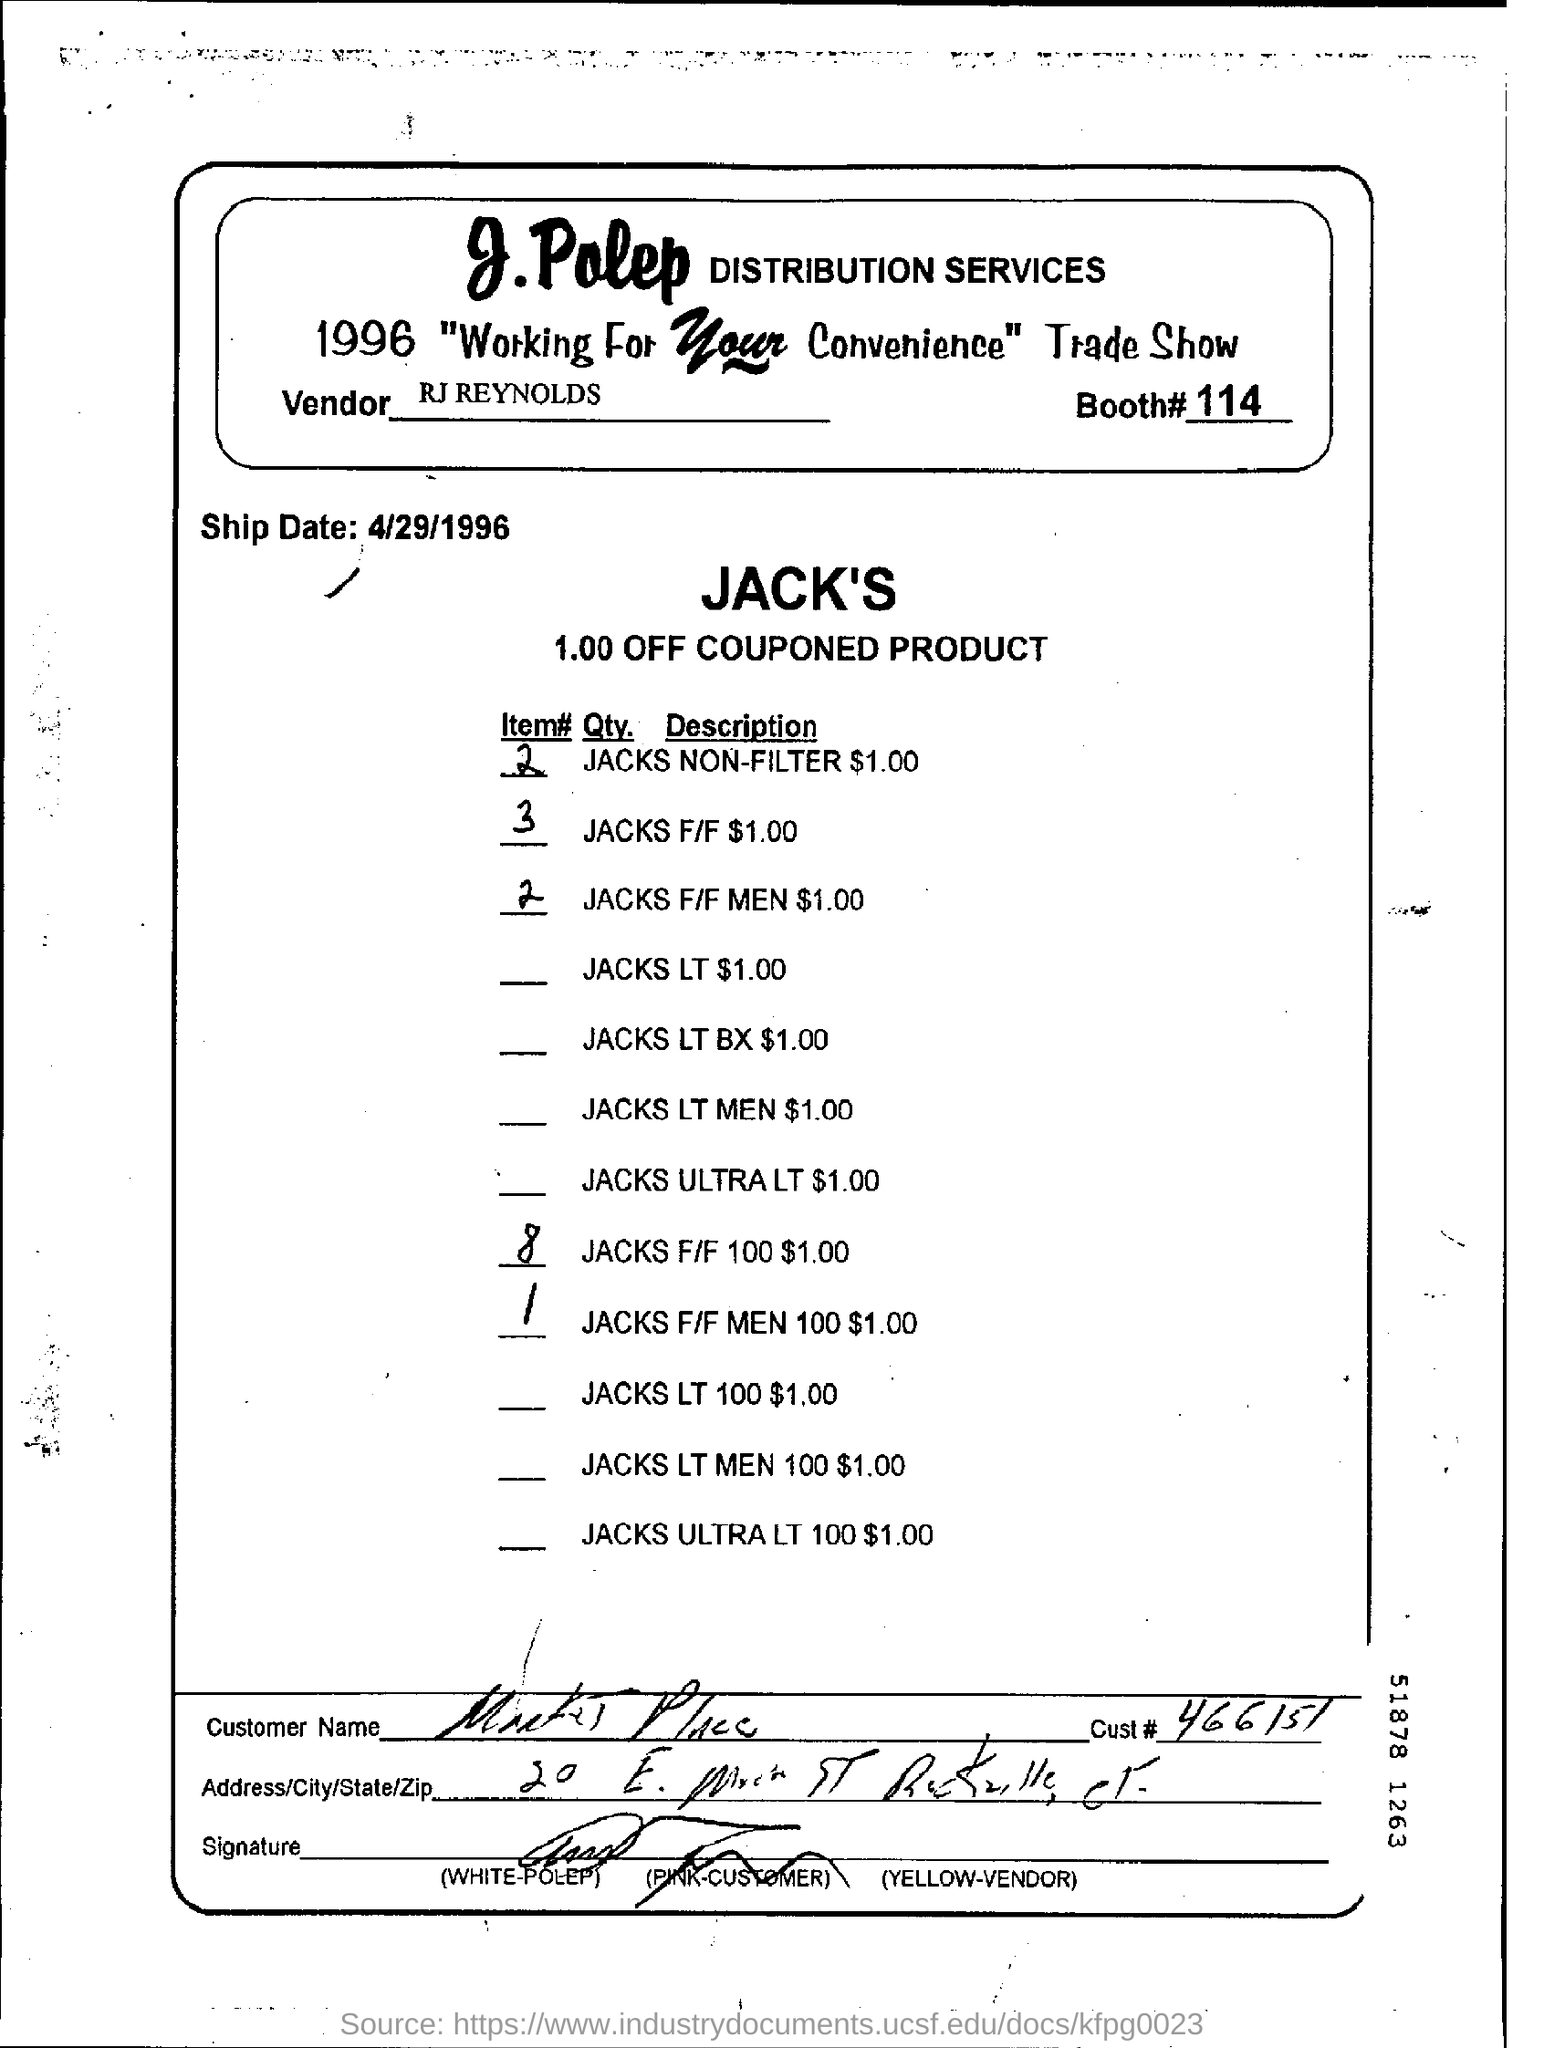Specify some key components in this picture. The booth number is 114. RJ Reynolds is the vendor. The ship date is April 29, 1996. What is the customer number? 466151... 